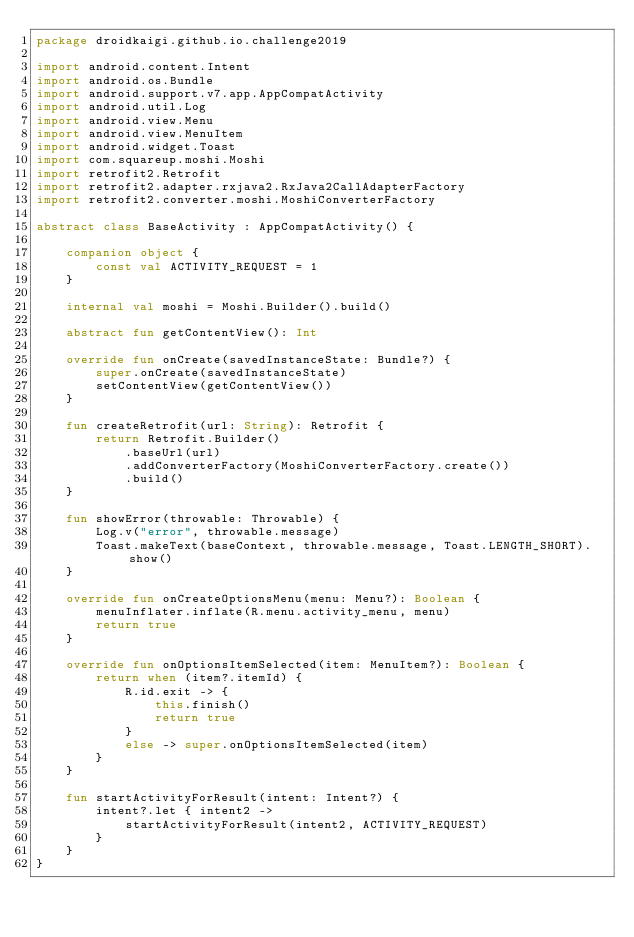Convert code to text. <code><loc_0><loc_0><loc_500><loc_500><_Kotlin_>package droidkaigi.github.io.challenge2019

import android.content.Intent
import android.os.Bundle
import android.support.v7.app.AppCompatActivity
import android.util.Log
import android.view.Menu
import android.view.MenuItem
import android.widget.Toast
import com.squareup.moshi.Moshi
import retrofit2.Retrofit
import retrofit2.adapter.rxjava2.RxJava2CallAdapterFactory
import retrofit2.converter.moshi.MoshiConverterFactory

abstract class BaseActivity : AppCompatActivity() {

    companion object {
        const val ACTIVITY_REQUEST = 1
    }

    internal val moshi = Moshi.Builder().build()

    abstract fun getContentView(): Int

    override fun onCreate(savedInstanceState: Bundle?) {
        super.onCreate(savedInstanceState)
        setContentView(getContentView())
    }

    fun createRetrofit(url: String): Retrofit {
        return Retrofit.Builder()
            .baseUrl(url)
            .addConverterFactory(MoshiConverterFactory.create())
            .build()
    }

    fun showError(throwable: Throwable) {
        Log.v("error", throwable.message)
        Toast.makeText(baseContext, throwable.message, Toast.LENGTH_SHORT).show()
    }

    override fun onCreateOptionsMenu(menu: Menu?): Boolean {
        menuInflater.inflate(R.menu.activity_menu, menu)
        return true
    }

    override fun onOptionsItemSelected(item: MenuItem?): Boolean {
        return when (item?.itemId) {
            R.id.exit -> {
                this.finish()
                return true
            }
            else -> super.onOptionsItemSelected(item)
        }
    }

    fun startActivityForResult(intent: Intent?) {
        intent?.let { intent2 ->
            startActivityForResult(intent2, ACTIVITY_REQUEST)
        }
    }
}</code> 